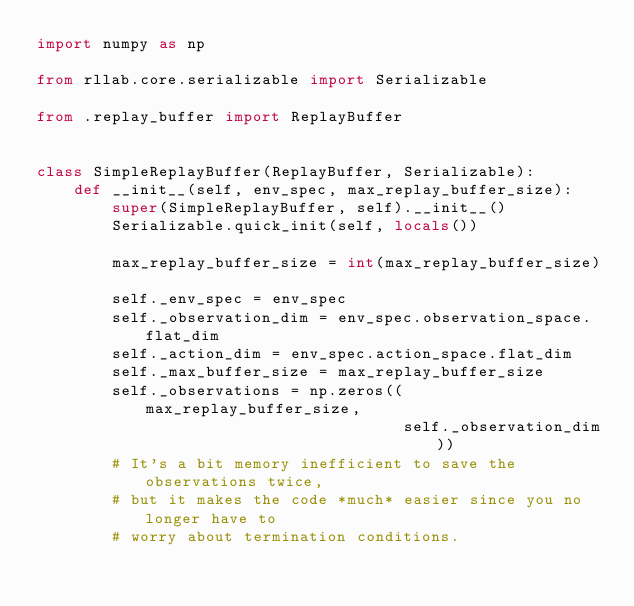Convert code to text. <code><loc_0><loc_0><loc_500><loc_500><_Python_>import numpy as np

from rllab.core.serializable import Serializable

from .replay_buffer import ReplayBuffer


class SimpleReplayBuffer(ReplayBuffer, Serializable):
    def __init__(self, env_spec, max_replay_buffer_size):
        super(SimpleReplayBuffer, self).__init__()
        Serializable.quick_init(self, locals())

        max_replay_buffer_size = int(max_replay_buffer_size)

        self._env_spec = env_spec
        self._observation_dim = env_spec.observation_space.flat_dim
        self._action_dim = env_spec.action_space.flat_dim
        self._max_buffer_size = max_replay_buffer_size
        self._observations = np.zeros((max_replay_buffer_size,
                                       self._observation_dim))
        # It's a bit memory inefficient to save the observations twice,
        # but it makes the code *much* easier since you no longer have to
        # worry about termination conditions.</code> 